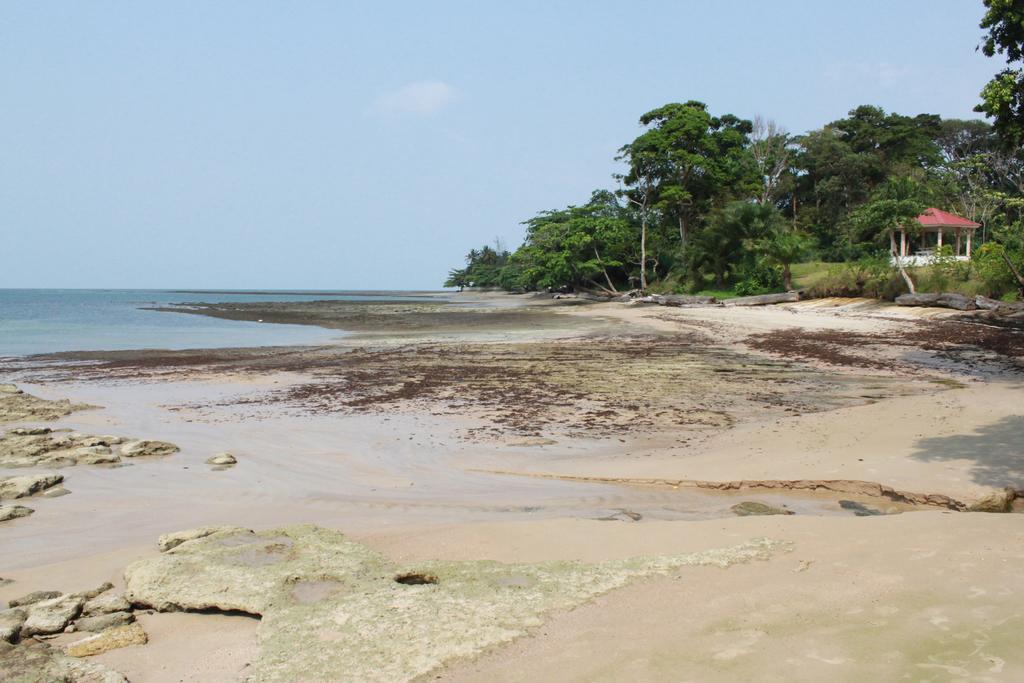Please provide a concise description of this image. In the foreground of this image, there is sand, few stones and water. In the background, there is a shelter, trees, sky, cloud and the water. 